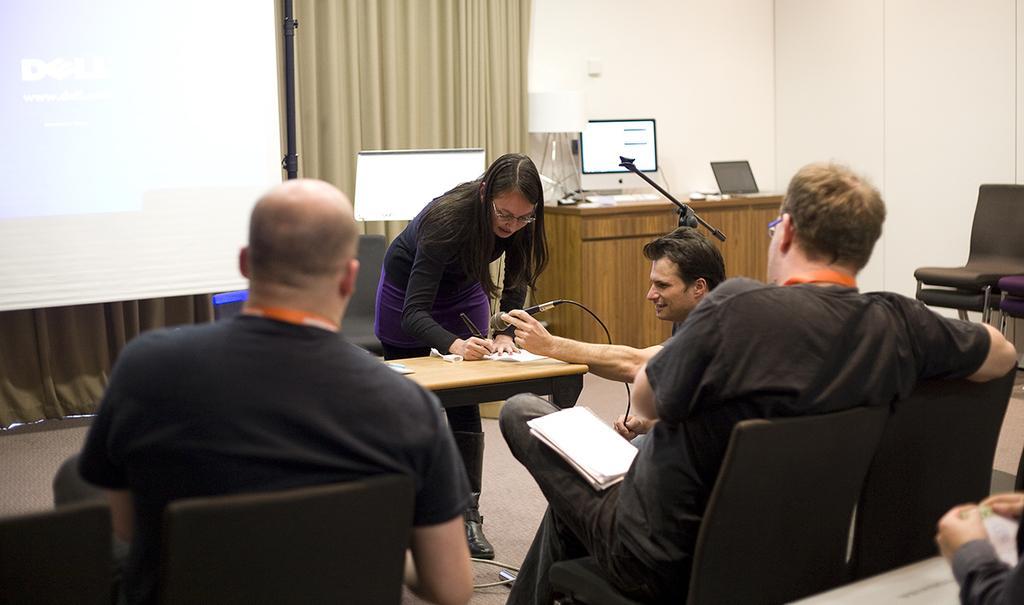Describe this image in one or two sentences. In this image we can see this people are sitting on chairs. This woman is standing near the table and writing with a pen. In the background we can see projector screen, curtains, table upon which monitor and laptop are placed. 